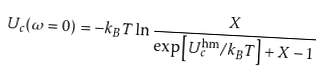<formula> <loc_0><loc_0><loc_500><loc_500>U _ { c } ( \omega = 0 ) = - k _ { B } T \ln \frac { X } { \exp \left [ U _ { c } ^ { \text {hm} } / k _ { B } T \right ] + X - 1 }</formula> 